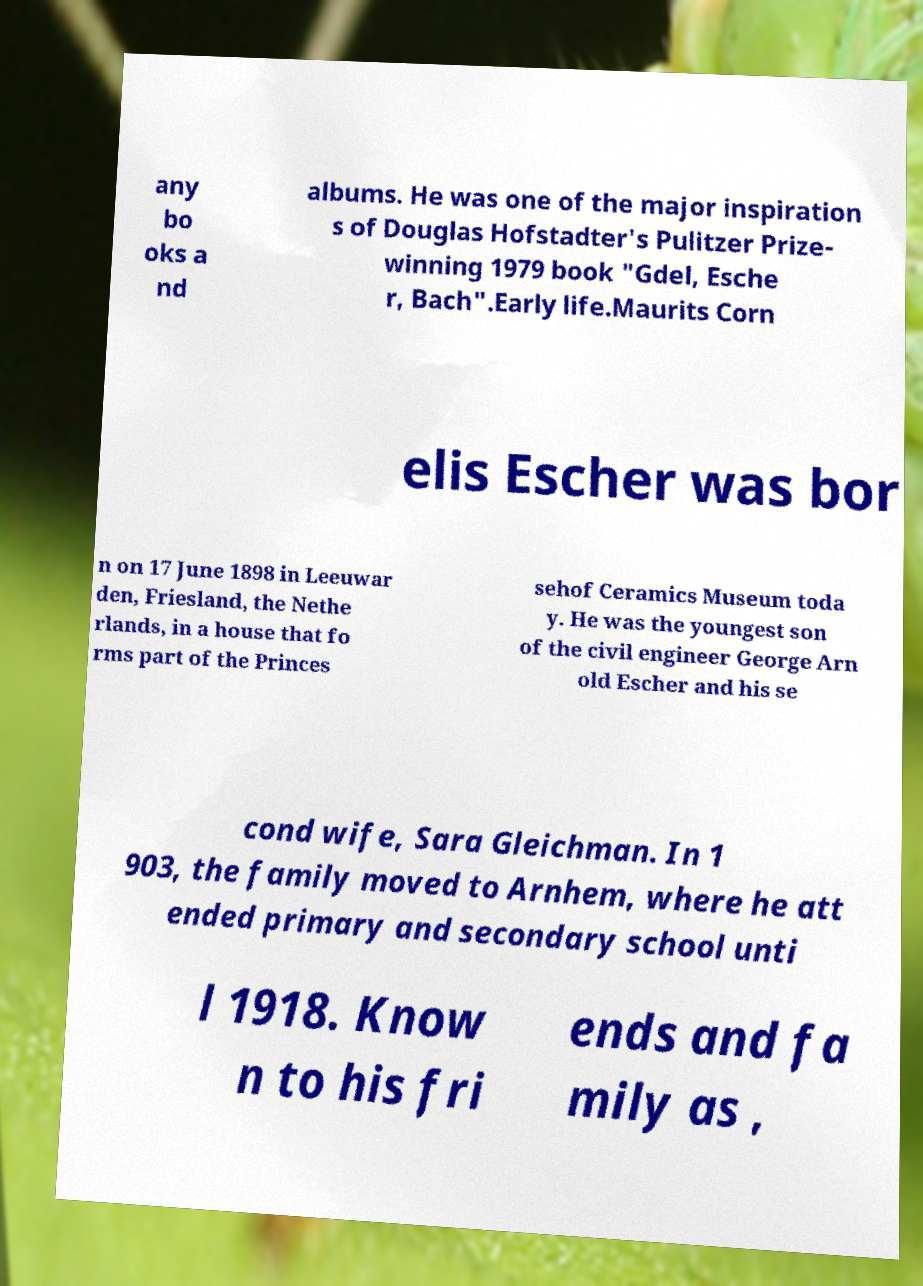Please read and relay the text visible in this image. What does it say? any bo oks a nd albums. He was one of the major inspiration s of Douglas Hofstadter's Pulitzer Prize- winning 1979 book "Gdel, Esche r, Bach".Early life.Maurits Corn elis Escher was bor n on 17 June 1898 in Leeuwar den, Friesland, the Nethe rlands, in a house that fo rms part of the Princes sehof Ceramics Museum toda y. He was the youngest son of the civil engineer George Arn old Escher and his se cond wife, Sara Gleichman. In 1 903, the family moved to Arnhem, where he att ended primary and secondary school unti l 1918. Know n to his fri ends and fa mily as , 